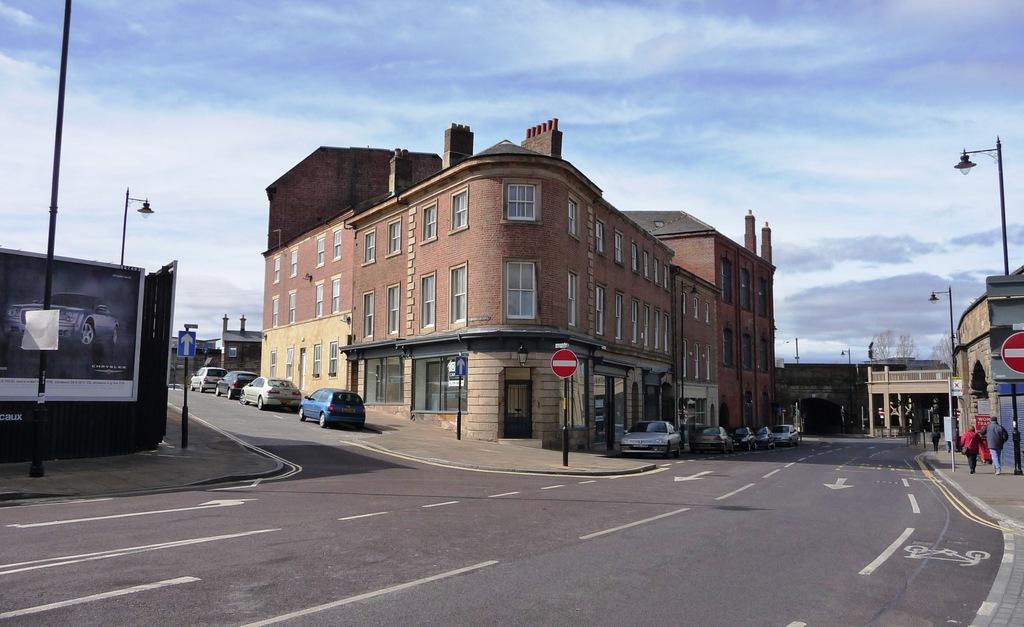Describe this image in one or two sentences. There are few cars on the road and there are buildings on either sides of it. 